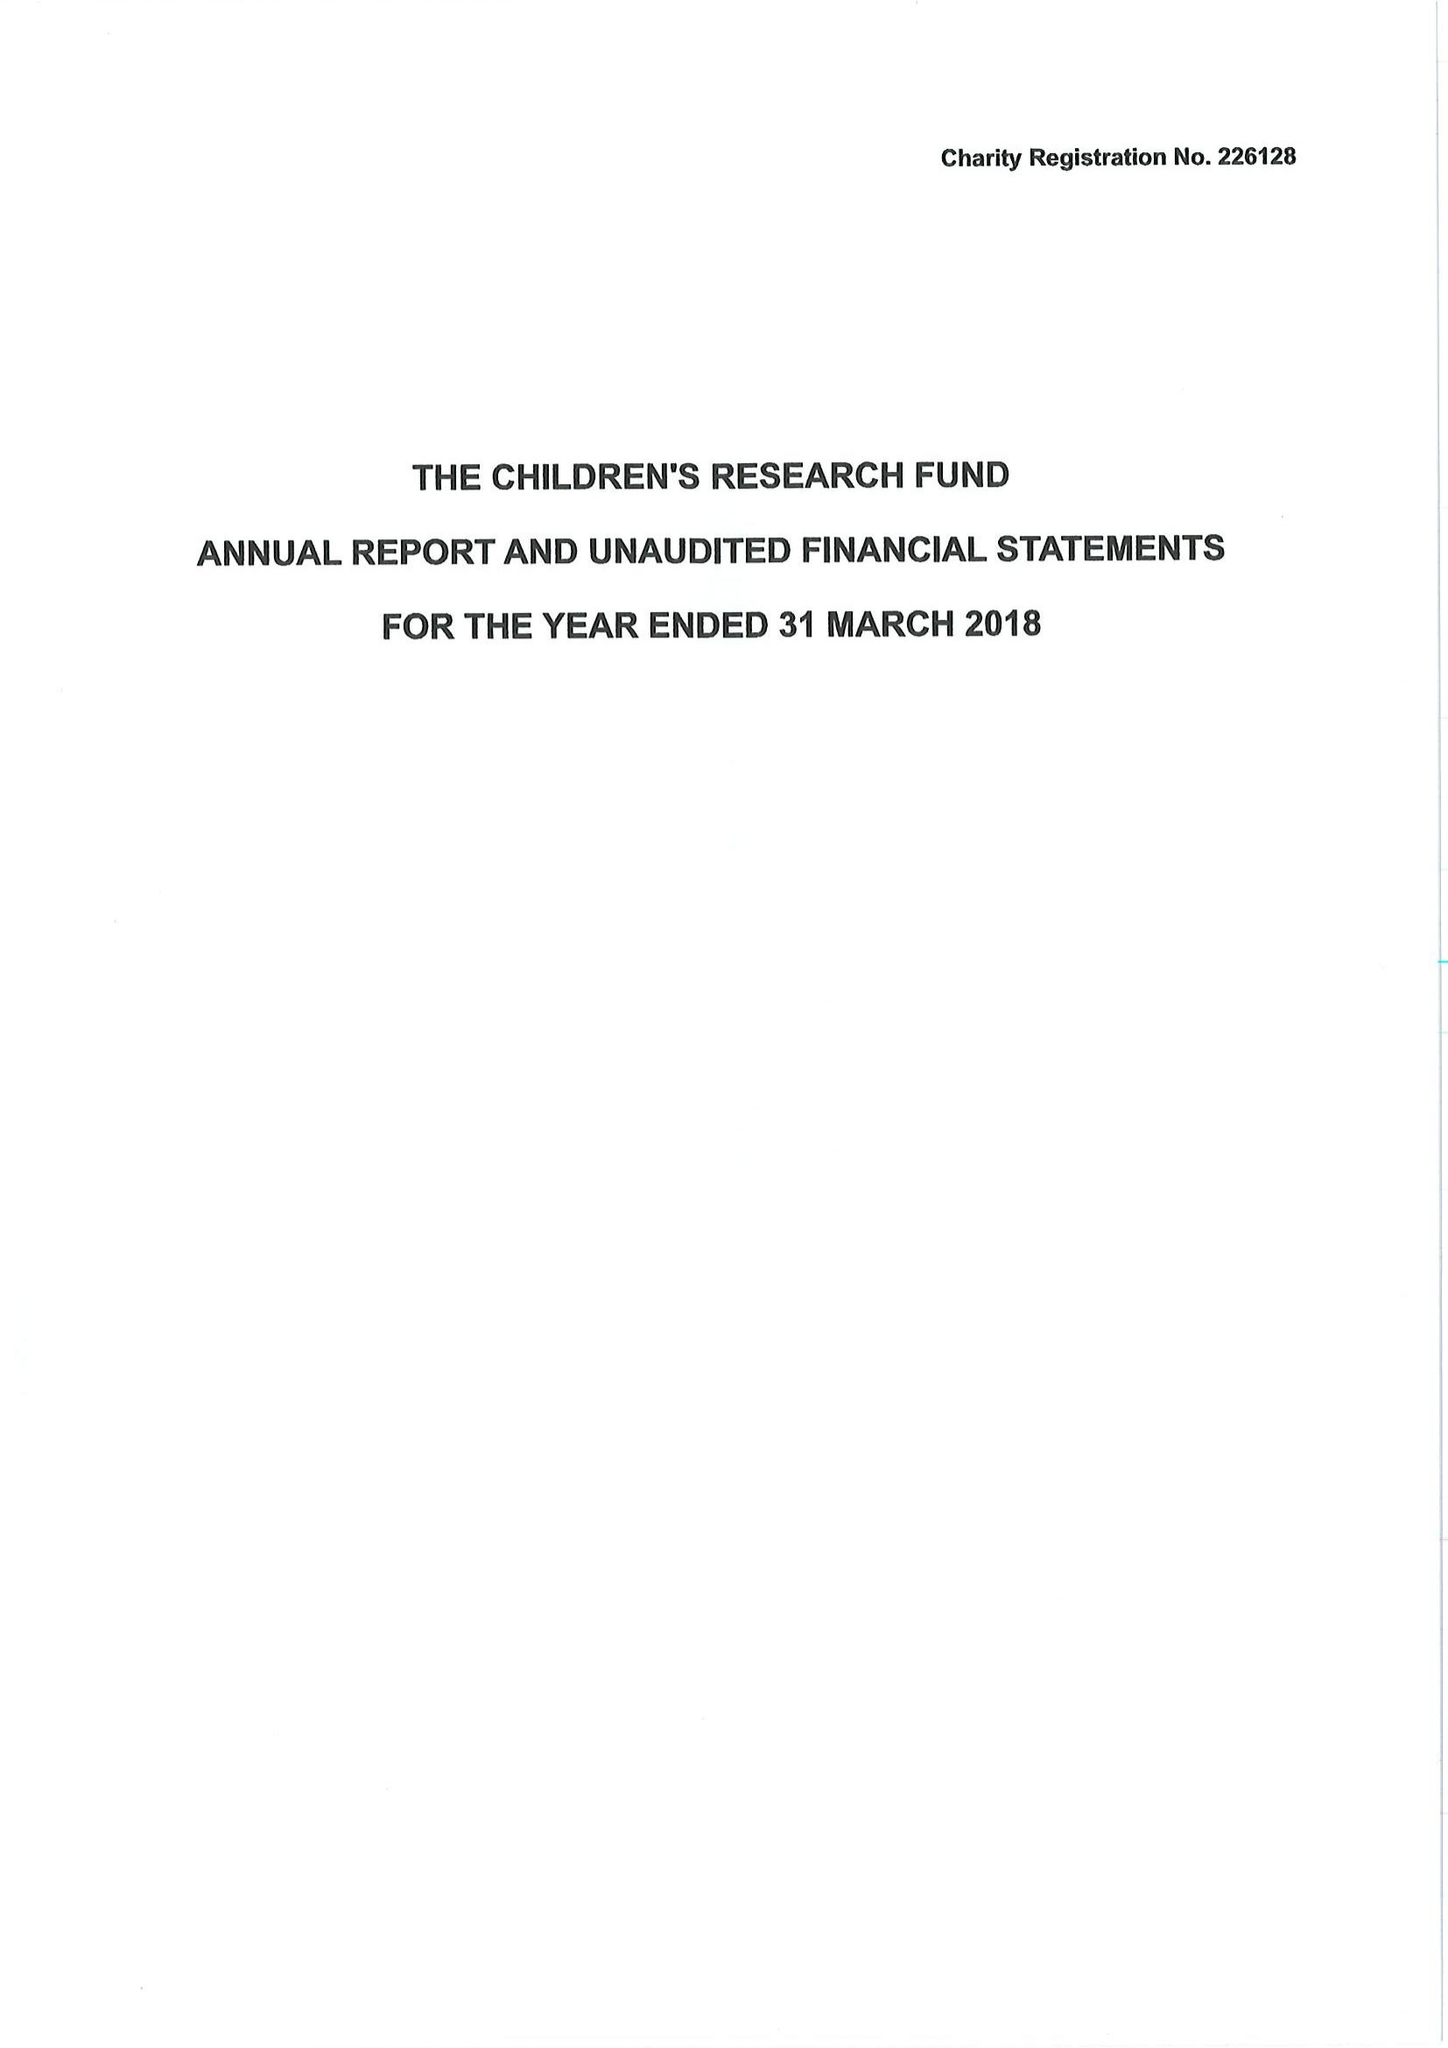What is the value for the income_annually_in_british_pounds?
Answer the question using a single word or phrase. 464053.00 